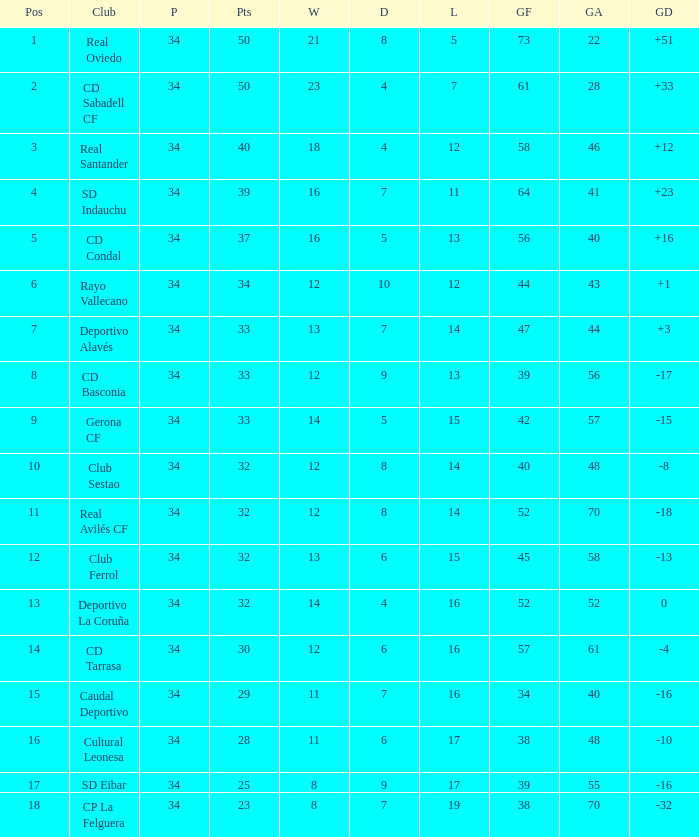Which played has draws below 7, and goals for below 61, and goals against below 48, and a position of 5? 34.0. 